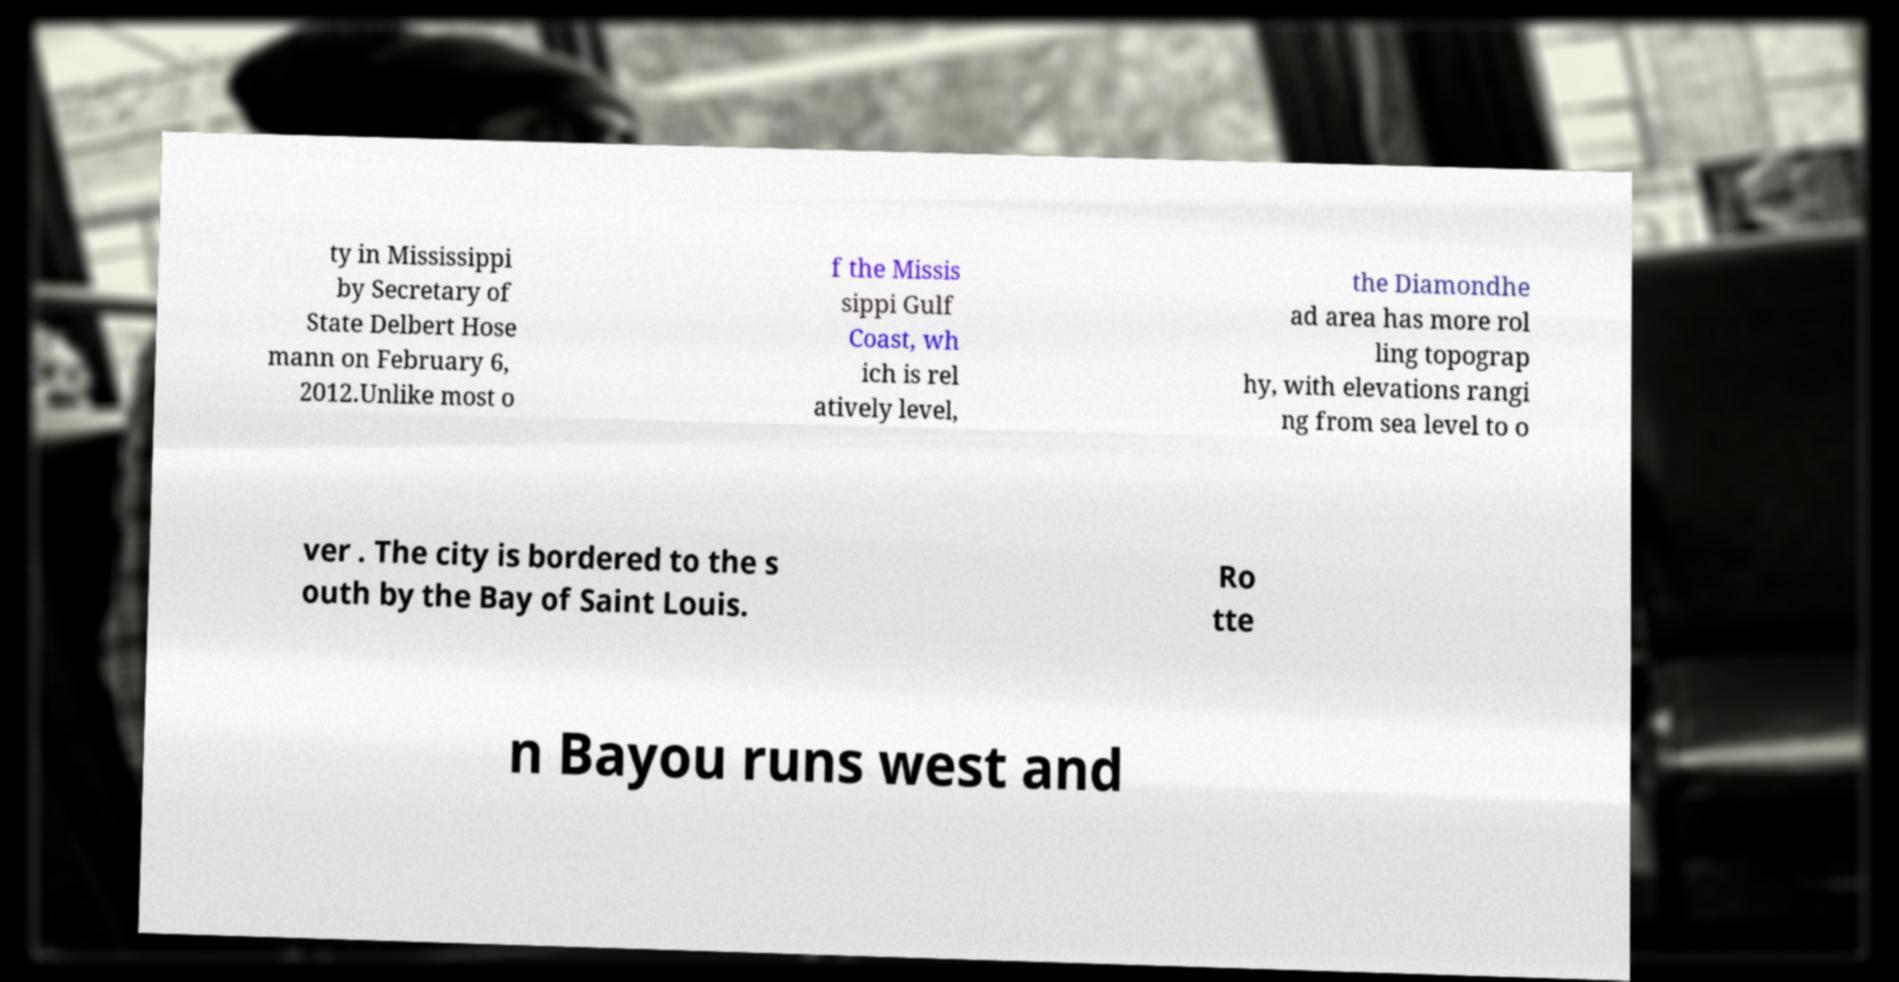For documentation purposes, I need the text within this image transcribed. Could you provide that? ty in Mississippi by Secretary of State Delbert Hose mann on February 6, 2012.Unlike most o f the Missis sippi Gulf Coast, wh ich is rel atively level, the Diamondhe ad area has more rol ling topograp hy, with elevations rangi ng from sea level to o ver . The city is bordered to the s outh by the Bay of Saint Louis. Ro tte n Bayou runs west and 